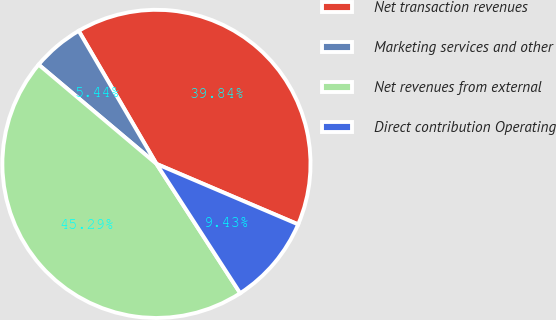Convert chart. <chart><loc_0><loc_0><loc_500><loc_500><pie_chart><fcel>Net transaction revenues<fcel>Marketing services and other<fcel>Net revenues from external<fcel>Direct contribution Operating<nl><fcel>39.84%<fcel>5.44%<fcel>45.29%<fcel>9.43%<nl></chart> 